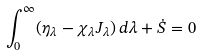Convert formula to latex. <formula><loc_0><loc_0><loc_500><loc_500>\int _ { 0 } ^ { \infty } ( \eta _ { \lambda } - \chi _ { \lambda } J _ { \lambda } ) \, d \lambda + \dot { S } = 0</formula> 